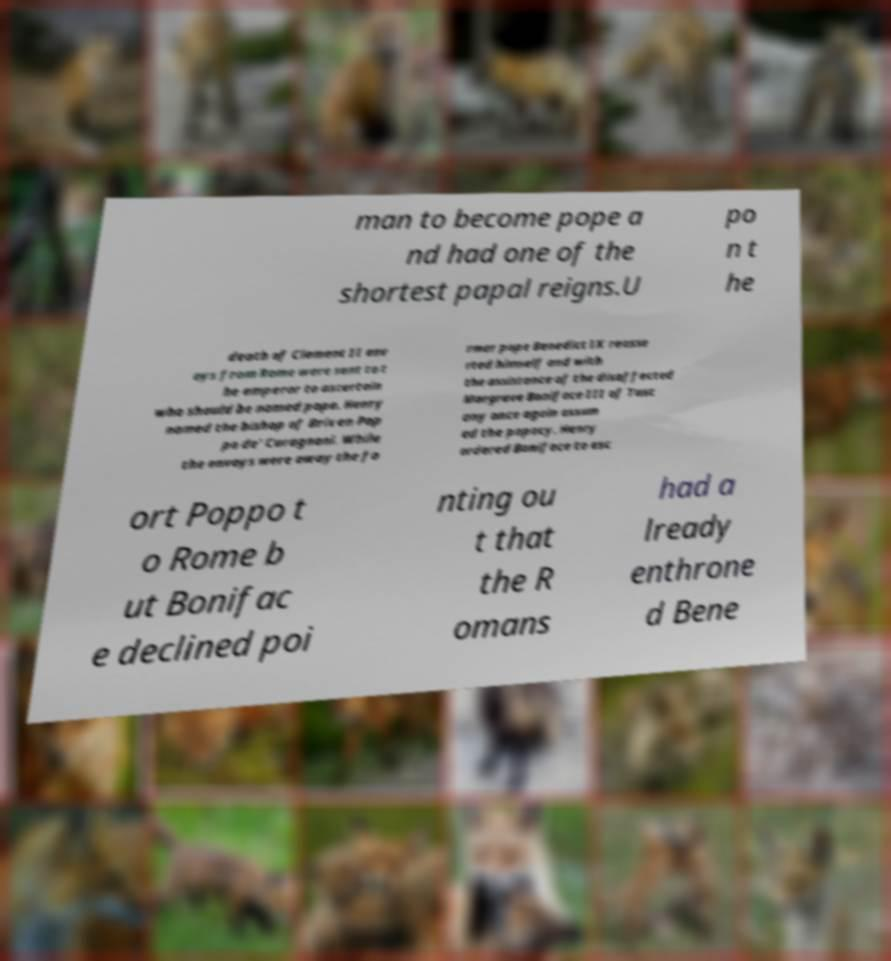Could you extract and type out the text from this image? man to become pope a nd had one of the shortest papal reigns.U po n t he death of Clement II env oys from Rome were sent to t he emperor to ascertain who should be named pope. Henry named the bishop of Brixen Pop po de' Curagnoni. While the envoys were away the fo rmer pope Benedict IX reasse rted himself and with the assistance of the disaffected Margrave Boniface III of Tusc any once again assum ed the papacy. Henry ordered Boniface to esc ort Poppo t o Rome b ut Bonifac e declined poi nting ou t that the R omans had a lready enthrone d Bene 